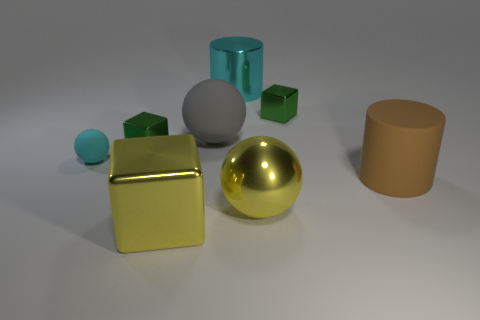Can you infer anything about the environment outside of the frame? While much of the environment is left to imagination, the soft, neutral background and diffuse lighting suggest an indoor setting. It is likely set in a controlled environment, potentially a studio, where the focus is purely on the shapes and materials of the objects presented. 